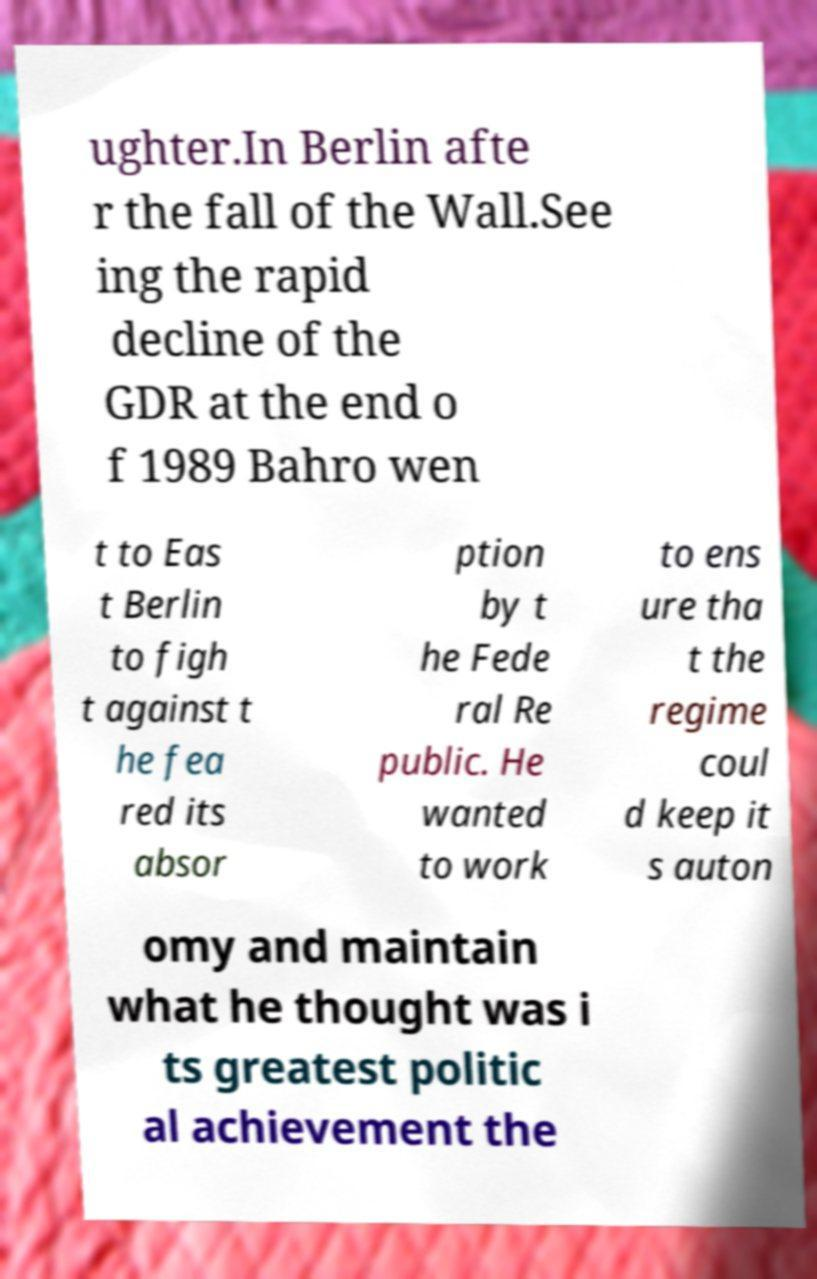Can you read and provide the text displayed in the image?This photo seems to have some interesting text. Can you extract and type it out for me? ughter.In Berlin afte r the fall of the Wall.See ing the rapid decline of the GDR at the end o f 1989 Bahro wen t to Eas t Berlin to figh t against t he fea red its absor ption by t he Fede ral Re public. He wanted to work to ens ure tha t the regime coul d keep it s auton omy and maintain what he thought was i ts greatest politic al achievement the 